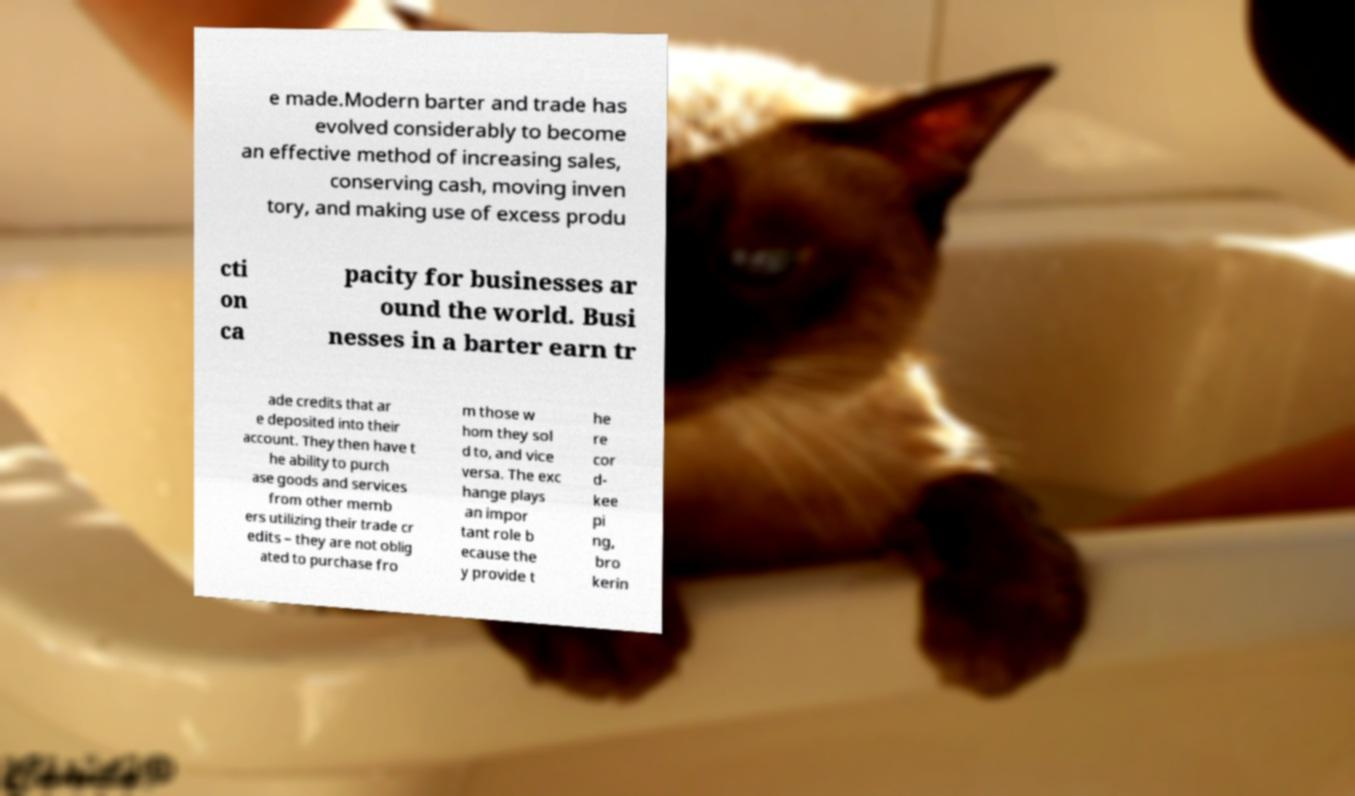Please identify and transcribe the text found in this image. e made.Modern barter and trade has evolved considerably to become an effective method of increasing sales, conserving cash, moving inven tory, and making use of excess produ cti on ca pacity for businesses ar ound the world. Busi nesses in a barter earn tr ade credits that ar e deposited into their account. They then have t he ability to purch ase goods and services from other memb ers utilizing their trade cr edits – they are not oblig ated to purchase fro m those w hom they sol d to, and vice versa. The exc hange plays an impor tant role b ecause the y provide t he re cor d- kee pi ng, bro kerin 